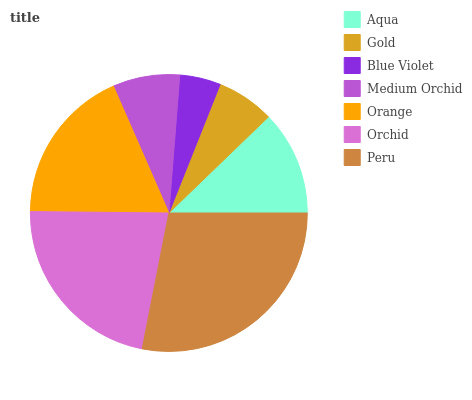Is Blue Violet the minimum?
Answer yes or no. Yes. Is Peru the maximum?
Answer yes or no. Yes. Is Gold the minimum?
Answer yes or no. No. Is Gold the maximum?
Answer yes or no. No. Is Aqua greater than Gold?
Answer yes or no. Yes. Is Gold less than Aqua?
Answer yes or no. Yes. Is Gold greater than Aqua?
Answer yes or no. No. Is Aqua less than Gold?
Answer yes or no. No. Is Aqua the high median?
Answer yes or no. Yes. Is Aqua the low median?
Answer yes or no. Yes. Is Gold the high median?
Answer yes or no. No. Is Blue Violet the low median?
Answer yes or no. No. 